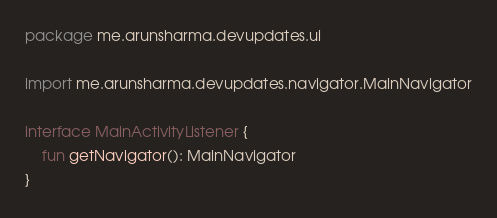Convert code to text. <code><loc_0><loc_0><loc_500><loc_500><_Kotlin_>package me.arunsharma.devupdates.ui

import me.arunsharma.devupdates.navigator.MainNavigator

interface MainActivityListener {
    fun getNavigator(): MainNavigator
}</code> 